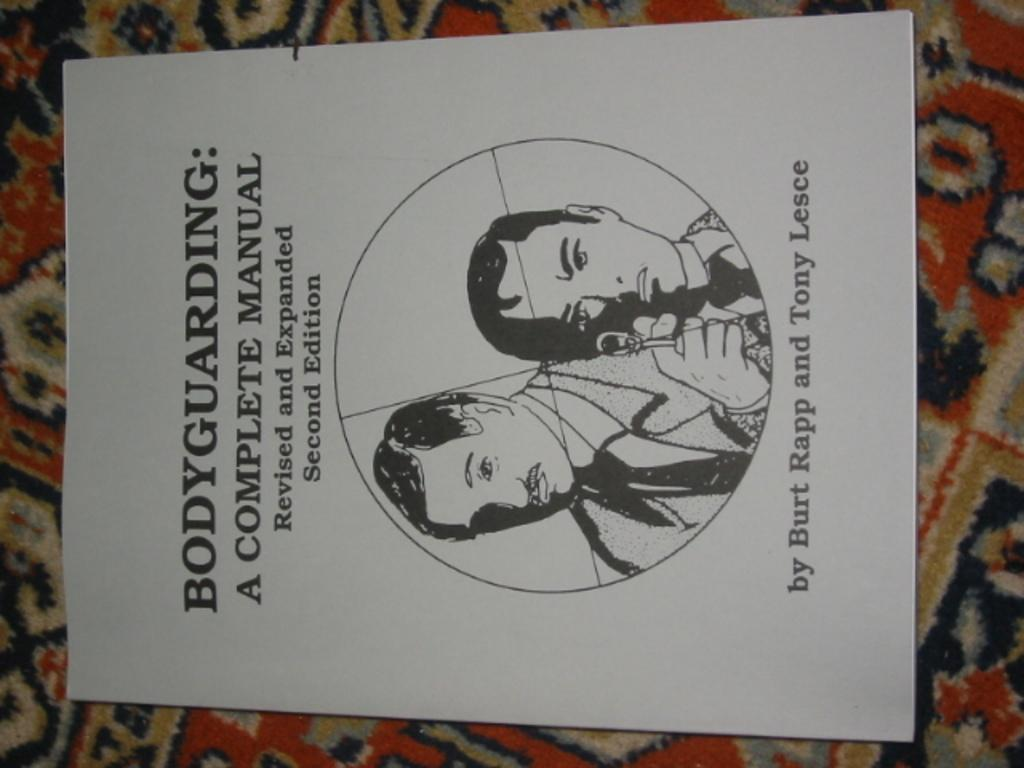<image>
Give a short and clear explanation of the subsequent image. Manual showing two men and the word "Bodyguarding" on top. 